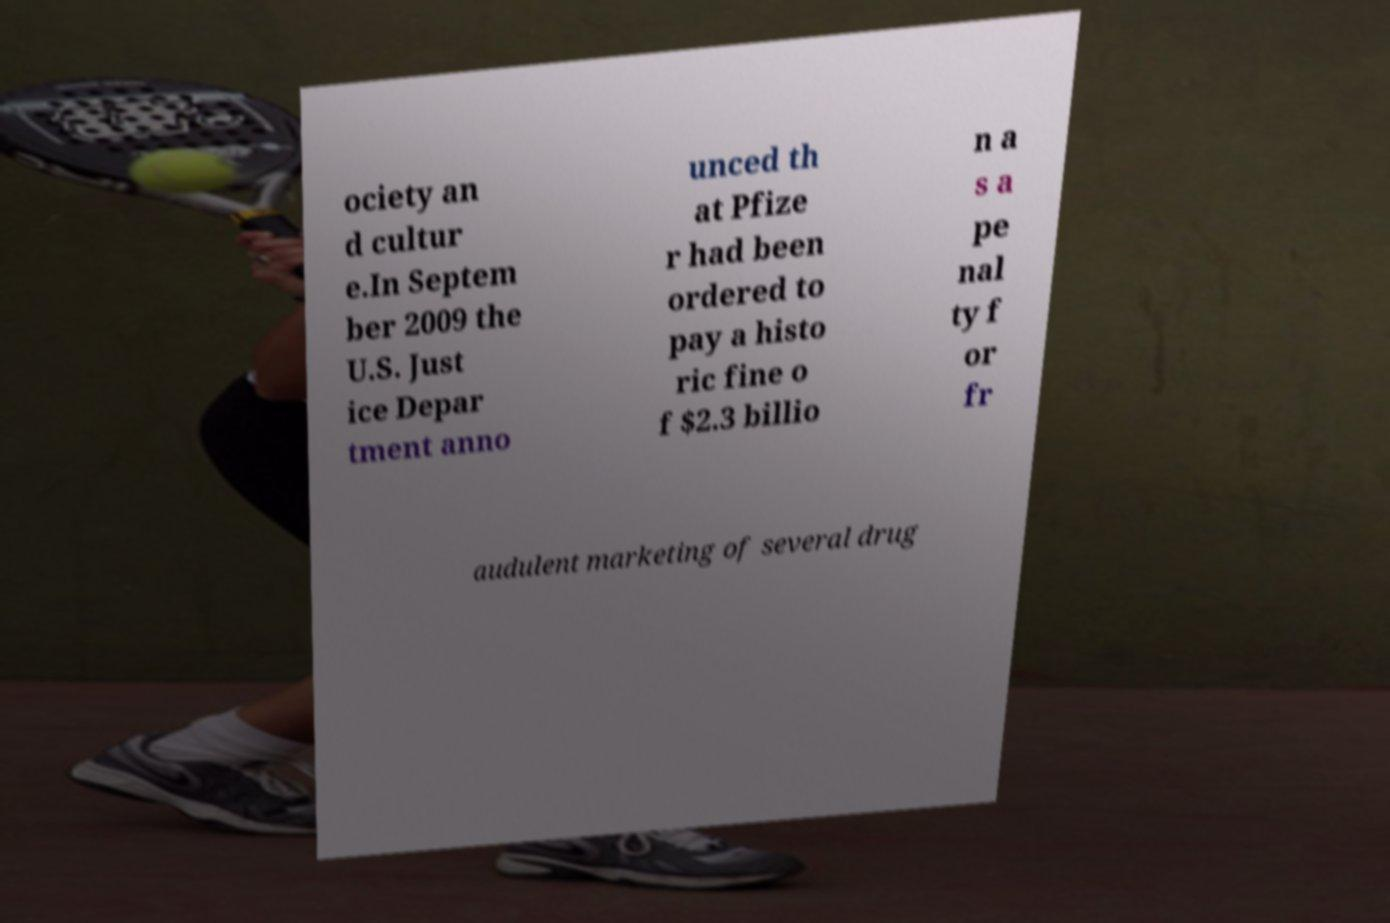Could you assist in decoding the text presented in this image and type it out clearly? ociety an d cultur e.In Septem ber 2009 the U.S. Just ice Depar tment anno unced th at Pfize r had been ordered to pay a histo ric fine o f $2.3 billio n a s a pe nal ty f or fr audulent marketing of several drug 